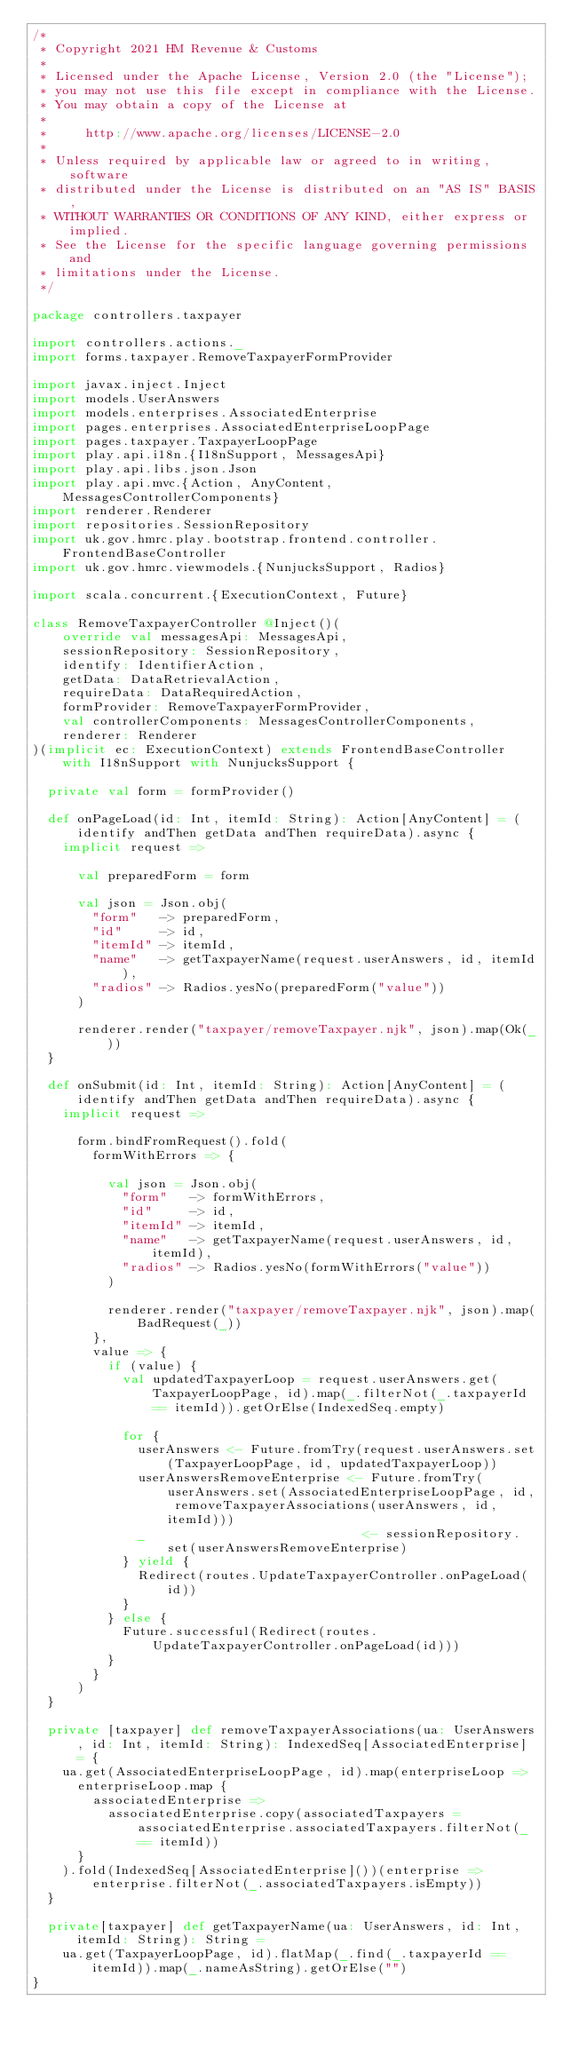Convert code to text. <code><loc_0><loc_0><loc_500><loc_500><_Scala_>/*
 * Copyright 2021 HM Revenue & Customs
 *
 * Licensed under the Apache License, Version 2.0 (the "License");
 * you may not use this file except in compliance with the License.
 * You may obtain a copy of the License at
 *
 *     http://www.apache.org/licenses/LICENSE-2.0
 *
 * Unless required by applicable law or agreed to in writing, software
 * distributed under the License is distributed on an "AS IS" BASIS,
 * WITHOUT WARRANTIES OR CONDITIONS OF ANY KIND, either express or implied.
 * See the License for the specific language governing permissions and
 * limitations under the License.
 */

package controllers.taxpayer

import controllers.actions._
import forms.taxpayer.RemoveTaxpayerFormProvider

import javax.inject.Inject
import models.UserAnswers
import models.enterprises.AssociatedEnterprise
import pages.enterprises.AssociatedEnterpriseLoopPage
import pages.taxpayer.TaxpayerLoopPage
import play.api.i18n.{I18nSupport, MessagesApi}
import play.api.libs.json.Json
import play.api.mvc.{Action, AnyContent, MessagesControllerComponents}
import renderer.Renderer
import repositories.SessionRepository
import uk.gov.hmrc.play.bootstrap.frontend.controller.FrontendBaseController
import uk.gov.hmrc.viewmodels.{NunjucksSupport, Radios}

import scala.concurrent.{ExecutionContext, Future}

class RemoveTaxpayerController @Inject()(
    override val messagesApi: MessagesApi,
    sessionRepository: SessionRepository,
    identify: IdentifierAction,
    getData: DataRetrievalAction,
    requireData: DataRequiredAction,
    formProvider: RemoveTaxpayerFormProvider,
    val controllerComponents: MessagesControllerComponents,
    renderer: Renderer
)(implicit ec: ExecutionContext) extends FrontendBaseController with I18nSupport with NunjucksSupport {

  private val form = formProvider()

  def onPageLoad(id: Int, itemId: String): Action[AnyContent] = (identify andThen getData andThen requireData).async {
    implicit request =>

      val preparedForm = form

      val json = Json.obj(
        "form"   -> preparedForm,
        "id"     -> id,
        "itemId" -> itemId,
        "name"   -> getTaxpayerName(request.userAnswers, id, itemId),
        "radios" -> Radios.yesNo(preparedForm("value"))
      )

      renderer.render("taxpayer/removeTaxpayer.njk", json).map(Ok(_))
  }

  def onSubmit(id: Int, itemId: String): Action[AnyContent] = (identify andThen getData andThen requireData).async {
    implicit request =>

      form.bindFromRequest().fold(
        formWithErrors => {

          val json = Json.obj(
            "form"   -> formWithErrors,
            "id"     -> id,
            "itemId" -> itemId,
            "name"   -> getTaxpayerName(request.userAnswers, id, itemId),
            "radios" -> Radios.yesNo(formWithErrors("value"))
          )

          renderer.render("taxpayer/removeTaxpayer.njk", json).map(BadRequest(_))
        },
        value => {
          if (value) {
            val updatedTaxpayerLoop = request.userAnswers.get(TaxpayerLoopPage, id).map(_.filterNot(_.taxpayerId == itemId)).getOrElse(IndexedSeq.empty)

            for {
              userAnswers <- Future.fromTry(request.userAnswers.set(TaxpayerLoopPage, id, updatedTaxpayerLoop))
              userAnswersRemoveEnterprise <- Future.fromTry(userAnswers.set(AssociatedEnterpriseLoopPage, id, removeTaxpayerAssociations(userAnswers, id, itemId)))
              _                             <- sessionRepository.set(userAnswersRemoveEnterprise)
            } yield {
              Redirect(routes.UpdateTaxpayerController.onPageLoad(id))
            }
          } else {
            Future.successful(Redirect(routes.UpdateTaxpayerController.onPageLoad(id)))
          }
        }
      )
  }

  private [taxpayer] def removeTaxpayerAssociations(ua: UserAnswers, id: Int, itemId: String): IndexedSeq[AssociatedEnterprise] = {
    ua.get(AssociatedEnterpriseLoopPage, id).map(enterpriseLoop =>
      enterpriseLoop.map {
        associatedEnterprise =>
          associatedEnterprise.copy(associatedTaxpayers =  associatedEnterprise.associatedTaxpayers.filterNot(_ == itemId))
      }
    ).fold(IndexedSeq[AssociatedEnterprise]())(enterprise => enterprise.filterNot(_.associatedTaxpayers.isEmpty))
  }

  private[taxpayer] def getTaxpayerName(ua: UserAnswers, id: Int, itemId: String): String =
    ua.get(TaxpayerLoopPage, id).flatMap(_.find(_.taxpayerId == itemId)).map(_.nameAsString).getOrElse("")
}
</code> 